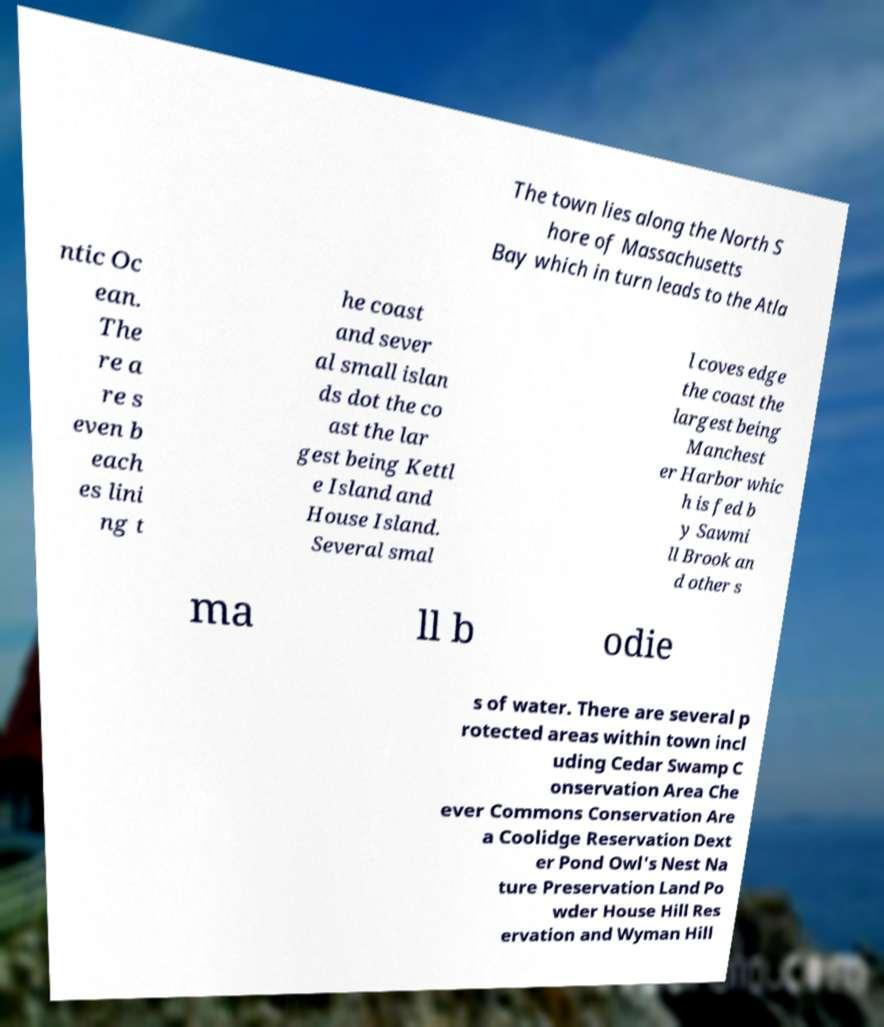For documentation purposes, I need the text within this image transcribed. Could you provide that? The town lies along the North S hore of Massachusetts Bay which in turn leads to the Atla ntic Oc ean. The re a re s even b each es lini ng t he coast and sever al small islan ds dot the co ast the lar gest being Kettl e Island and House Island. Several smal l coves edge the coast the largest being Manchest er Harbor whic h is fed b y Sawmi ll Brook an d other s ma ll b odie s of water. There are several p rotected areas within town incl uding Cedar Swamp C onservation Area Che ever Commons Conservation Are a Coolidge Reservation Dext er Pond Owl's Nest Na ture Preservation Land Po wder House Hill Res ervation and Wyman Hill 